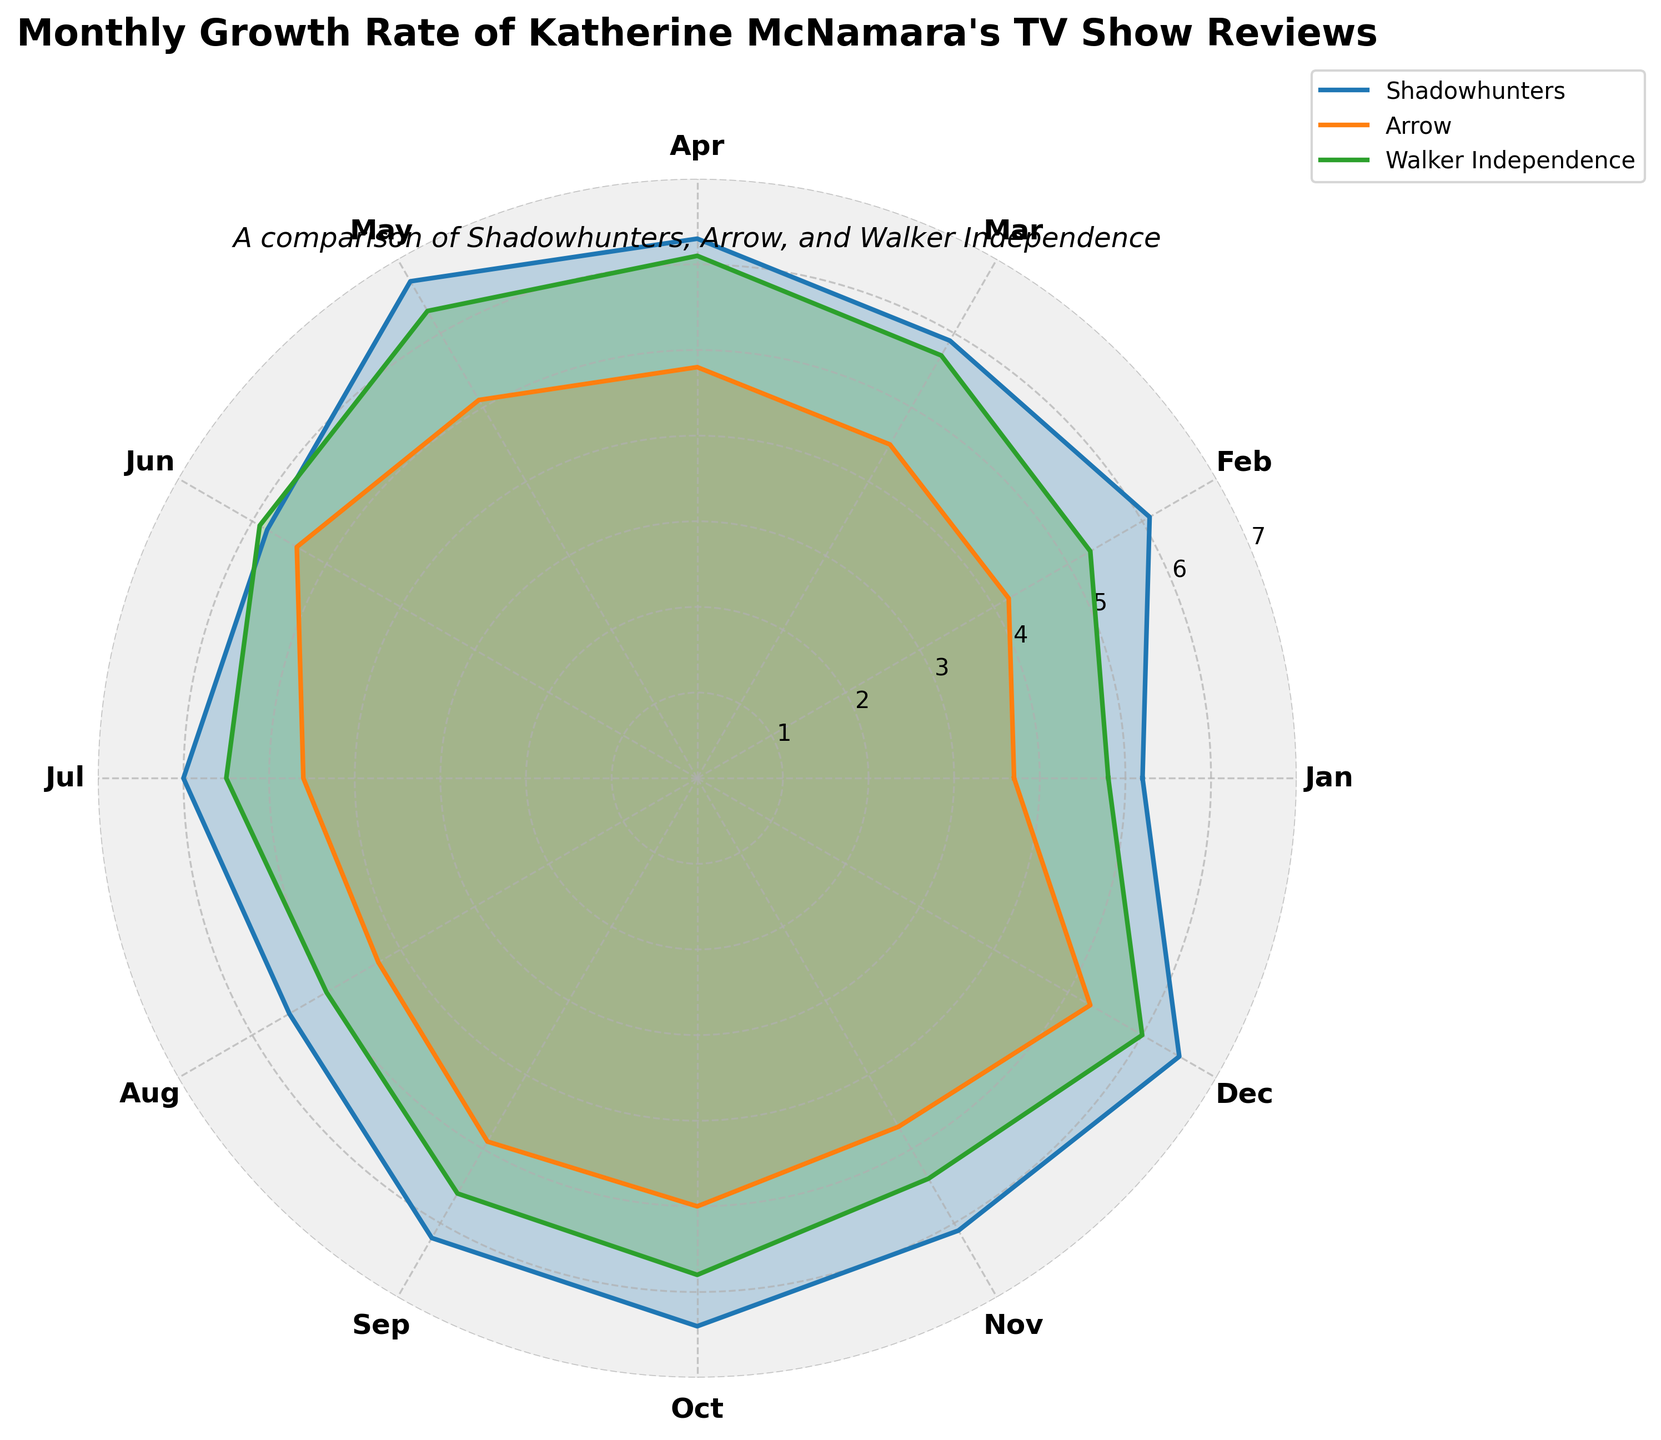What's the title of the chart? The title of the chart can be found at the top of the figure. It provides the main theme or subject of the visualization.
Answer: Monthly Growth Rate of Katherine McNamara's TV Show Reviews What are the three TV shows compared in the radar chart? The three TV shows are listed in the legend outside the plot area. These are Shadowhunters, Arrow, and Walker Independence.
Answer: Shadowhunters, Arrow, Walker Independence Which month shows the highest growth rate for 'Arrow'? Looking at the plot, identify the peak point of the 'Arrow' line and check the corresponding month on the x-axis.
Answer: June On average, which show has the highest growth rate across the months? Compare the overall shape and areas covered by each show's line and fill. Shadowhunters consistently covers higher values.
Answer: Shadowhunters Which month shows the smallest difference in growth rates between 'Shadowhunters' and 'Walker Independence'? Examine the lines for 'Shadowhunters' and 'Walker Independence' to find the month where the values are closest to each other.
Answer: May In which month does 'Walker Independence' have a growth rate higher than both 'Shadowhunters' and 'Arrow'? Check each segment of the radar chart for the months where Walker Independence's line is above both other lines.
Answer: May What is the average growth rate of 'Shadowhunters' over the 12 months? Calculate the sum of Shadowhunters' growth rates from each month and divide by 12. (5.2 + 6.1 + 5.9 + 6.3 + 6.7 + 5.8 + 6.0 + 5.5 + 6.2 + 6.4 + 6.1 + 6.5) ÷ 12 = 6.00
Answer: 6.00 Compare the growth rates of 'Walker Independence' in January and December. Which month had a higher rate? Look at the chart to identify the values for Walker Independence in January and December. January shows 4.8 and December shows 6.0.
Answer: December Which month has the smallest growth rate for 'Walker Independence'? Identify the lowest point of the Walker Independence line on the chart and see the corresponding month.
Answer: January Do 'Arrow' and 'Shadowhunters' ever have the same growth rate in any month? Check each segment of the radar chart to see if the 'Arrow' and 'Shadowhunters' lines overlap exactly in any month.
Answer: No 